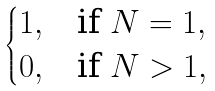<formula> <loc_0><loc_0><loc_500><loc_500>\begin{cases} 1 , & \text {if } N = 1 , \\ 0 , & \text {if } N > 1 , \end{cases}</formula> 